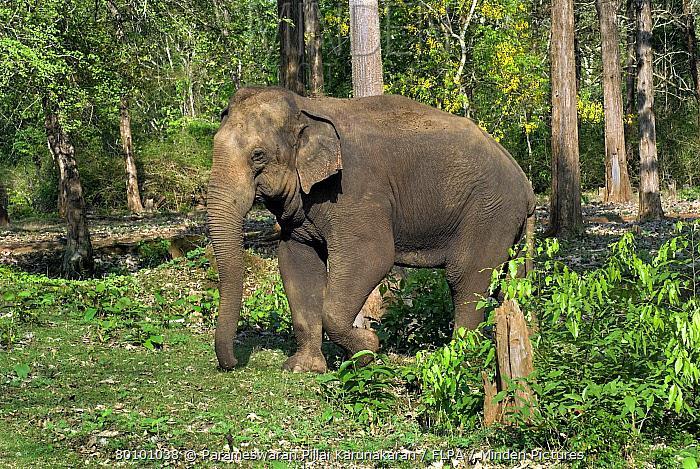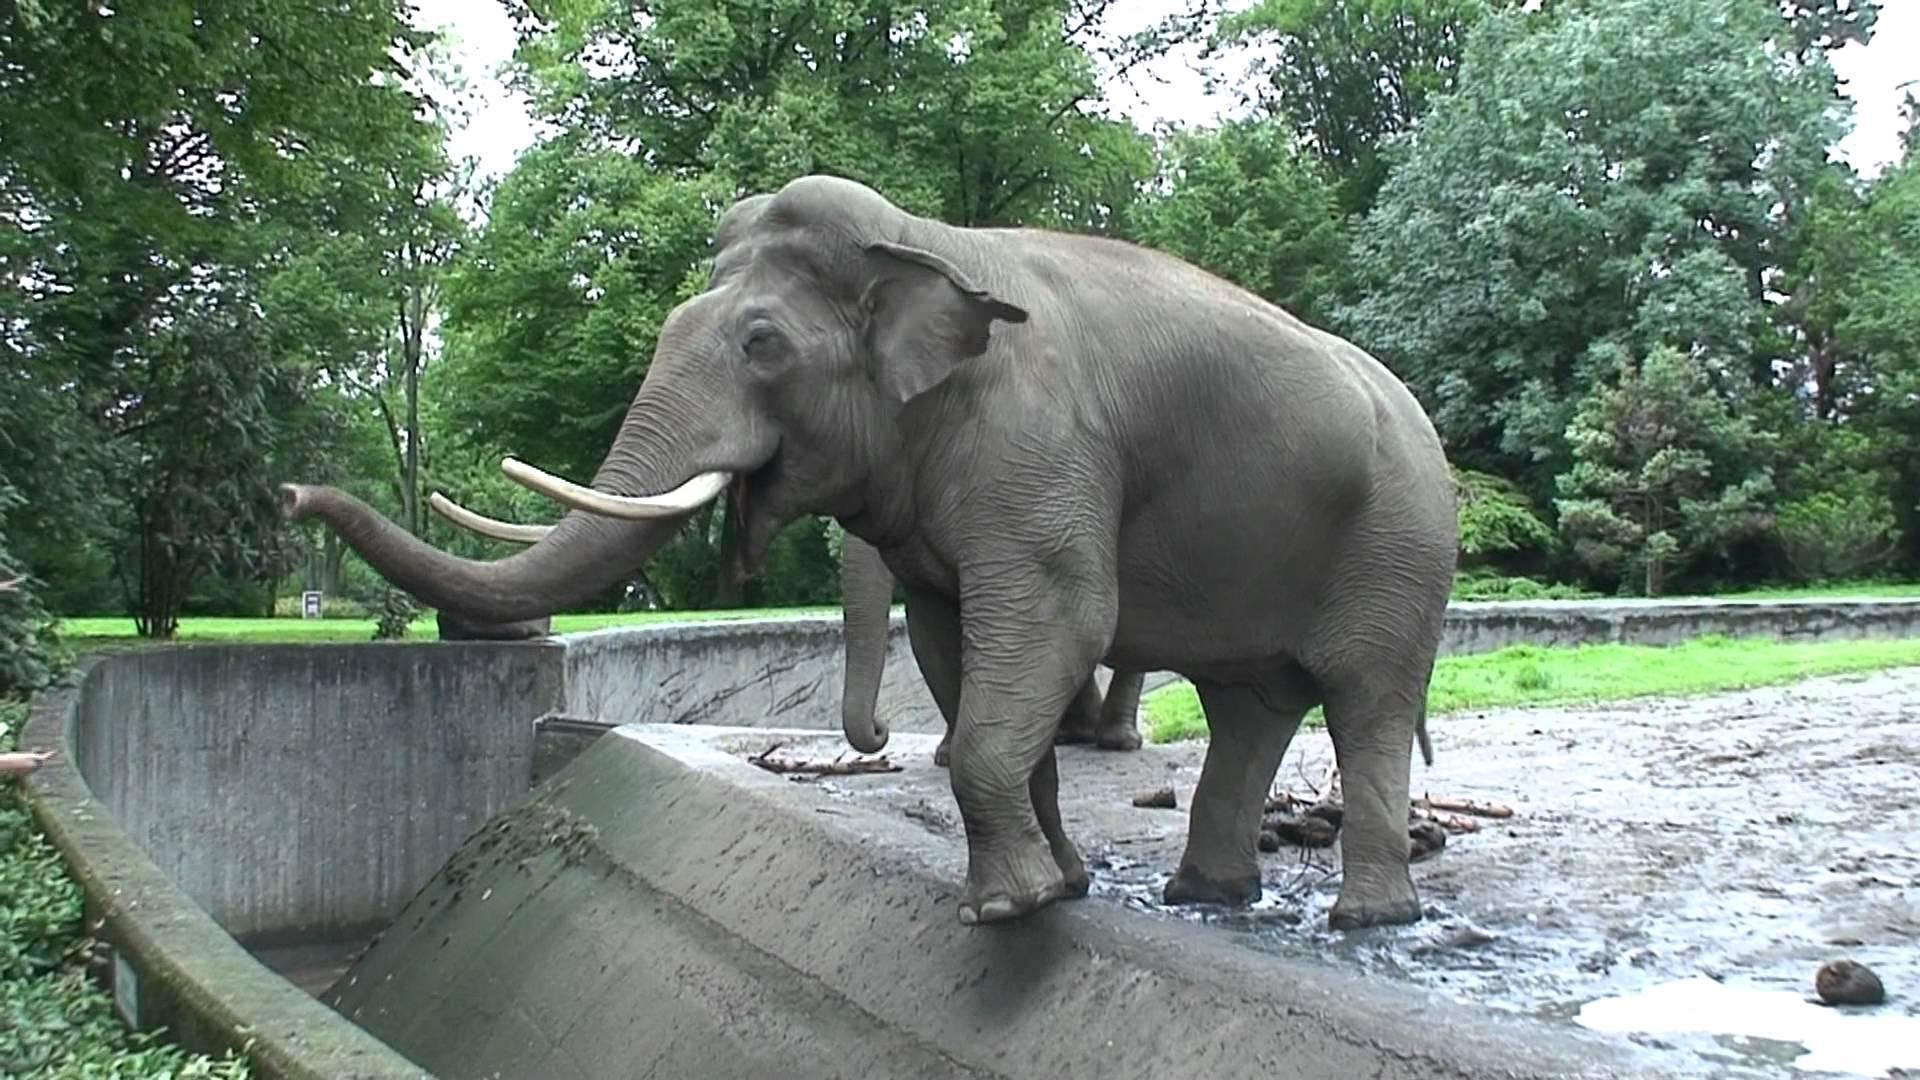The first image is the image on the left, the second image is the image on the right. Analyze the images presented: Is the assertion "One image shows an elephant with large tusks." valid? Answer yes or no. Yes. The first image is the image on the left, the second image is the image on the right. Examine the images to the left and right. Is the description "Three elephants in total." accurate? Answer yes or no. No. 